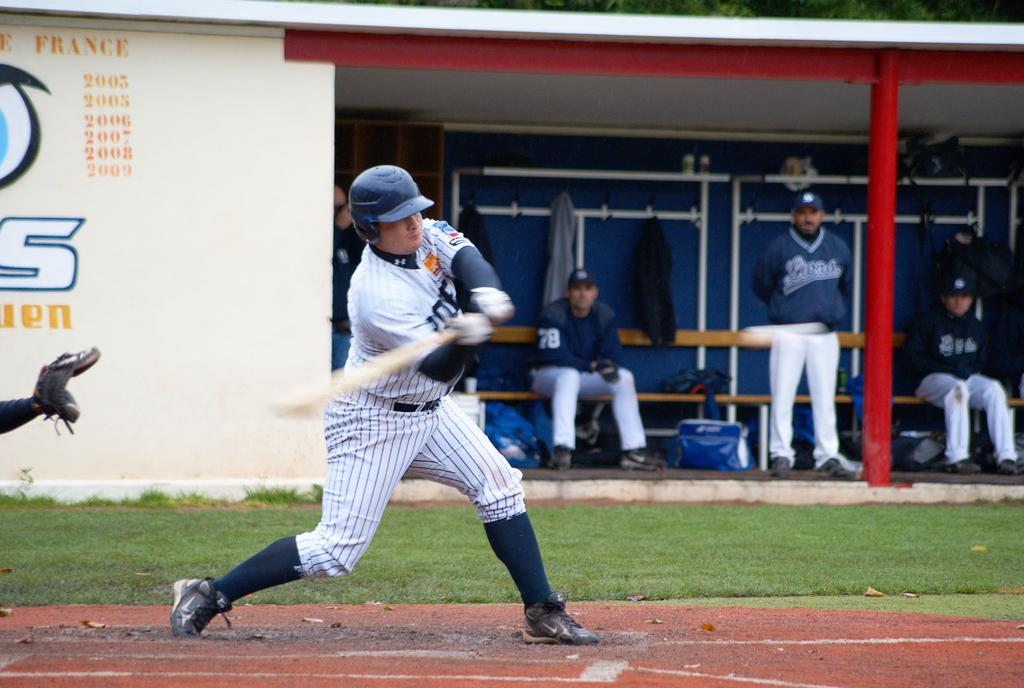<image>
Give a short and clear explanation of the subsequent image. Baesball player hitting the ball in front of a wall that says France on it. 